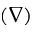Convert formula to latex. <formula><loc_0><loc_0><loc_500><loc_500>( \nabla )</formula> 